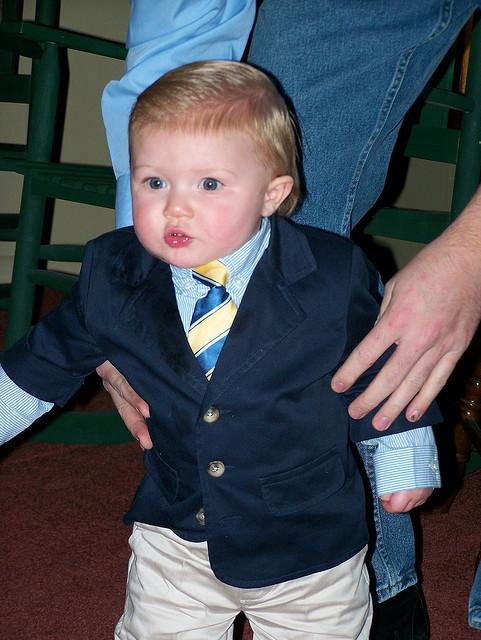What color is the jacket on the boy?
Keep it brief. Blue. What is around his neck?
Quick response, please. Tie. What color is the baby's jacket?
Be succinct. Blue. How many buttons are on his jacket?
Write a very short answer. 3. Is the boy standing on his own?
Be succinct. No. 